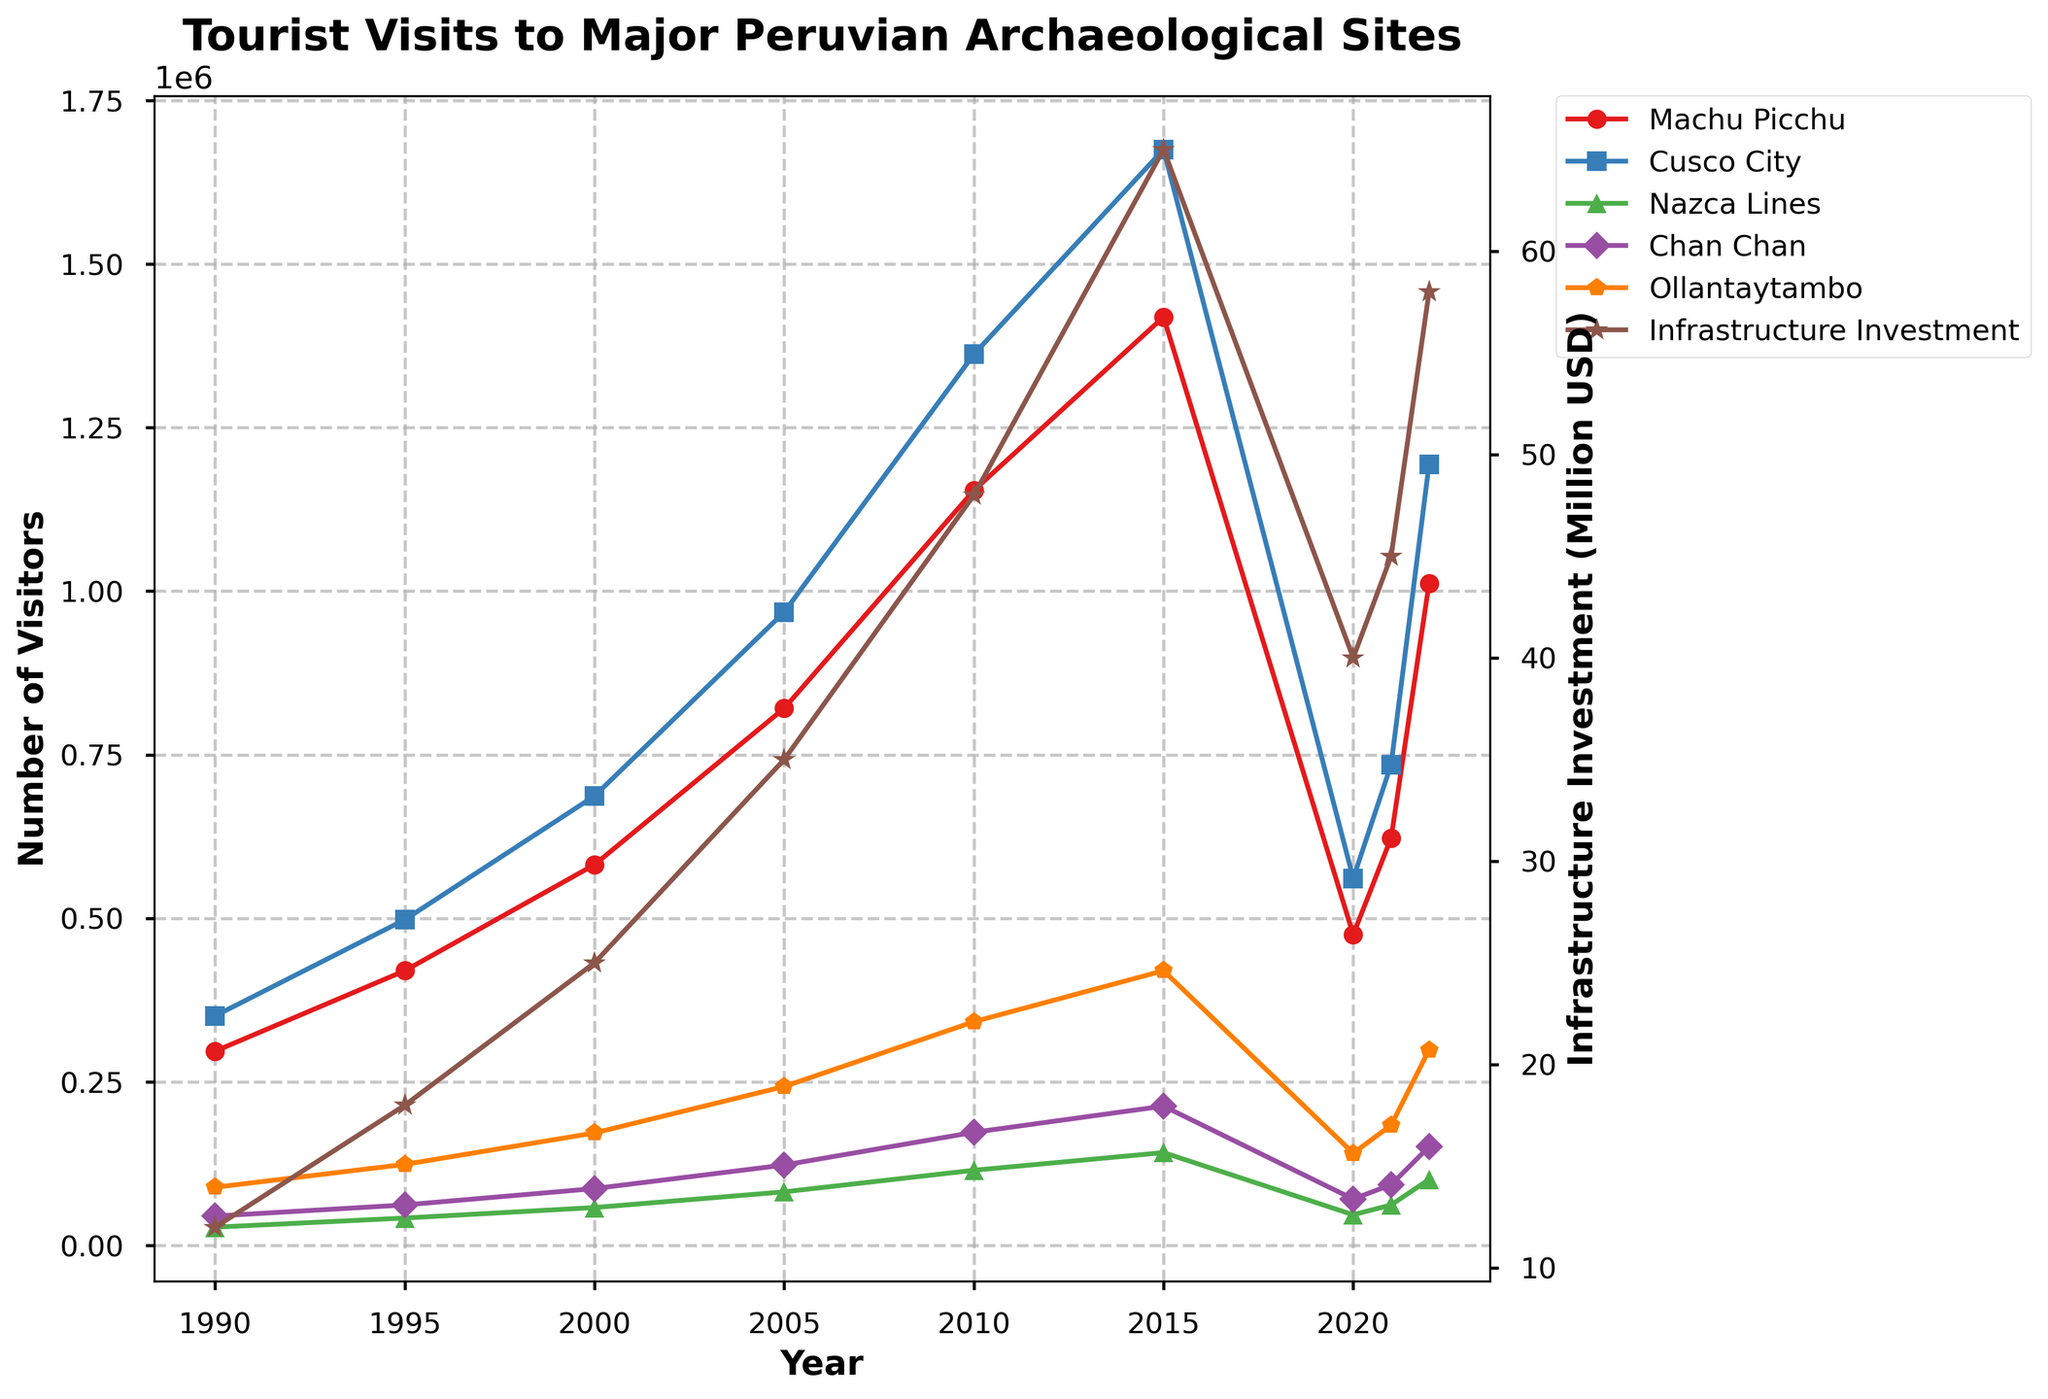What is the trend in the number of visitors to Machu Picchu from 1990 to 2022? From 1990 to 2022, the number of visitors to Machu Picchu has generally increased, with a peak in 2015 before a decline in 2020 and a recent recovery up to 2022. This trend can be observed by looking at the plot line for Machu Picchu, which rises sharply from left to right with a slight drop around 2020, then rising again.
Answer: Increasing How does the number of visitors to Cusco City in 1990 compare to the number in 2022? To compare the number of visitors to Cusco City in 1990 and 2022, we look at the specific points on the plot for those years. In 1990, the number is 351,000 and in 2022, it is 1,194,000.
Answer: Increased Which archaeological site had the highest visitor count in 2010 and by how much? In 2010, the highest visitor count can be found by comparing the points on the plot for that year. Machu Picchu had the highest count with 1,154,000 visitors.
Answer: Machu Picchu (1,154,000) What was the pattern of infrastructure investment from 1990 to 2022? The pattern shows a general increase in infrastructure investment over the years, with a more pronounced rise from 2000 onwards, as seen from the plot line for infrastructure investment which trends upwards with a notable dip around 2020 and a subsequent recovery.
Answer: Increasing What was the largest reduction in visitors to any archaeological site between any two consecutive years shown? The largest reduction in visitors is observed for Machu Picchu between 2015 and 2020. The visitor count dropped from 1,419,000 in 2015 to 475,000 in 2020, a reduction of 944,000 visitors.
Answer: 944,000 Compare the visitor trends between Nazca Lines and Chan Chan over the entire period. Both archaeological sites show an overall increasing trend in visitor numbers from 1990 to 2022. However, Nazca Lines shows a steadier, less steep rise while Chan Chan experiences more significant increases over time, particularly noticeable closer to 2022.
Answer: Both Increased; Chan Chan steeper In which year was the infrastructure investment equal to the average investment over the entire period? The average infrastructure investment from 1990 to 2022 is calculated by summing the investment values and dividing by the number of years. The sum is 366, and the average is 366 / 9 ≈ 40.7 million USD. The investment value closest to 40.7 million USD is in 2020 (40 million USD).
Answer: 2020 Which site's visitor pattern most closely correlates with the infrastructure investment trend? To determine the closest correlation, we visually compare the patterns of site visits with the infrastructure investment line. Machu Picchu’s visitor pattern appears to most closely follow the trend of infrastructure investment, with both showing significant rises and similar dips around 2020 before recovery.
Answer: Machu Picchu Between which two consecutive years was the greatest increase in infrastructure investment observed? To find the greatest increase, compare the differences between consecutive years. The greatest increase is between 2015 and 2020, where the investment rose from 65 million USD to 40 million USD, an increment of 25 million USD.
Answer: Between 2010 and 2015 What is the relationship between infrastructure investment and visitor numbers across all sites? We can observe from the plotted lines that generally, as infrastructure investment increases, so do the visitor numbers across all sites. Significant investments seem to correlate with higher visitor counts, suggesting a positive relationship where increased infrastructure funding supports higher tourist attendance.
Answer: Positive correlation 